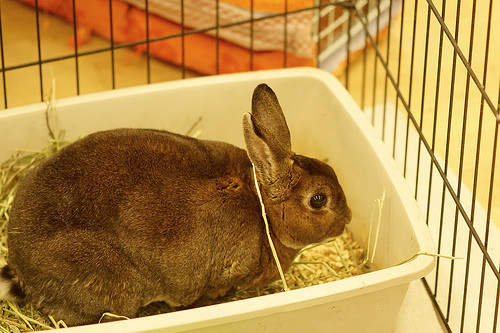<image>
Can you confirm if the bunny is in the cage? Yes. The bunny is contained within or inside the cage, showing a containment relationship. 